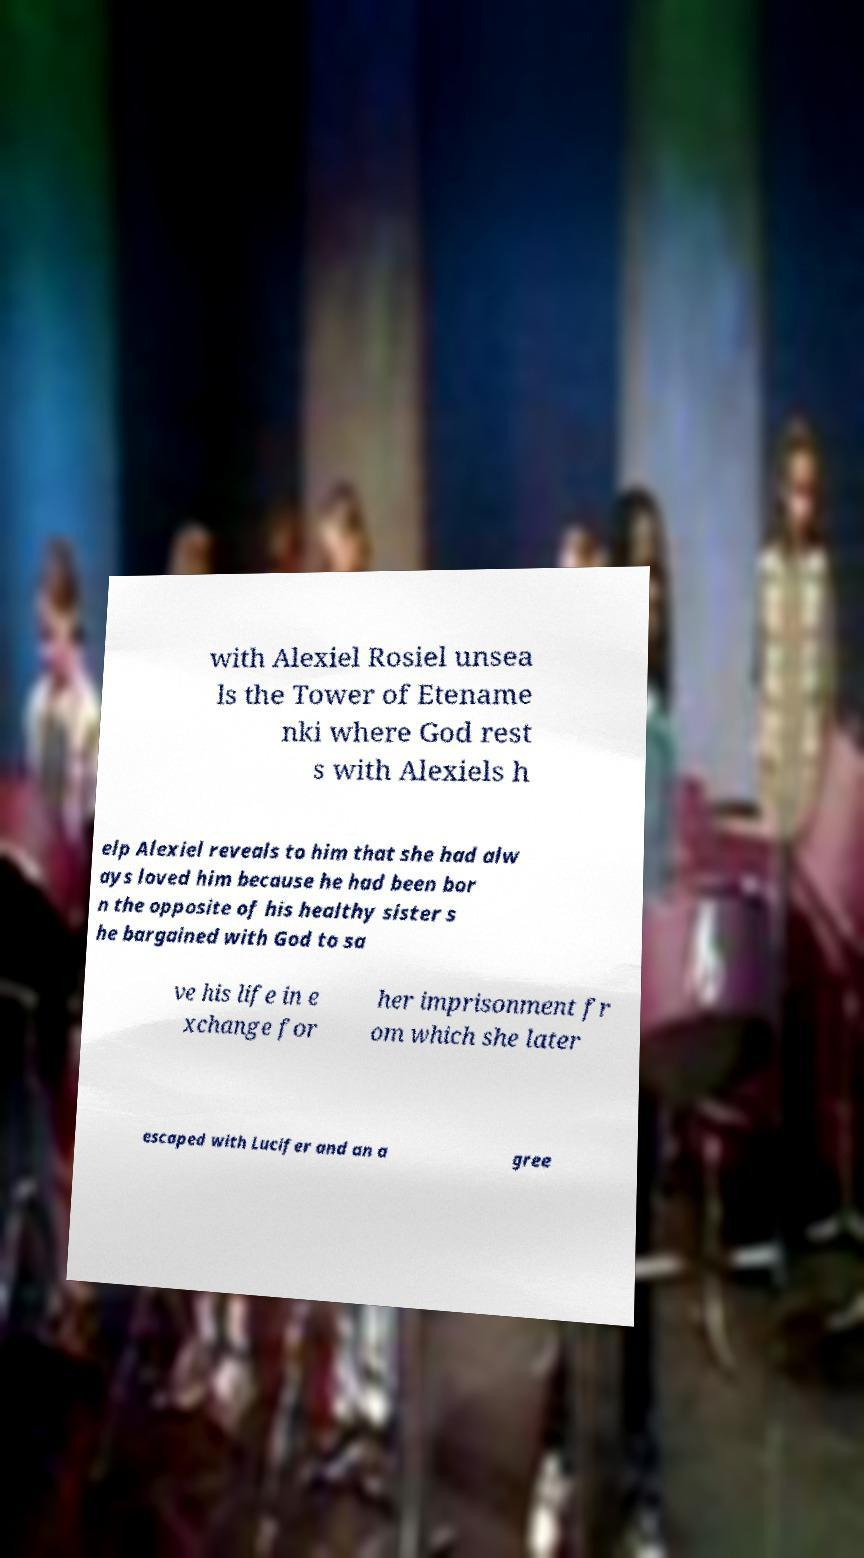What messages or text are displayed in this image? I need them in a readable, typed format. with Alexiel Rosiel unsea ls the Tower of Etename nki where God rest s with Alexiels h elp Alexiel reveals to him that she had alw ays loved him because he had been bor n the opposite of his healthy sister s he bargained with God to sa ve his life in e xchange for her imprisonment fr om which she later escaped with Lucifer and an a gree 